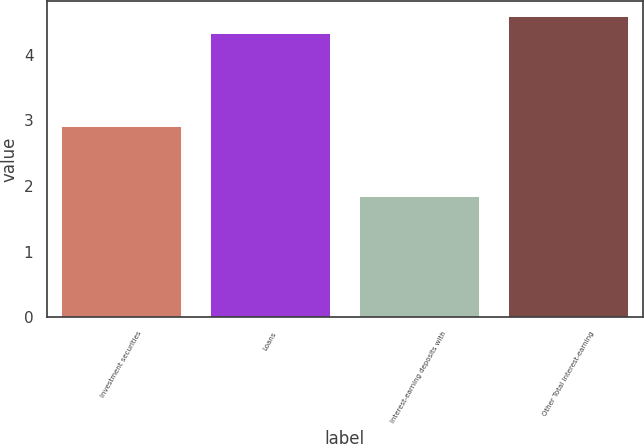Convert chart. <chart><loc_0><loc_0><loc_500><loc_500><bar_chart><fcel>Investment securities<fcel>Loans<fcel>Interest-earning deposits with<fcel>Other Total interest-earning<nl><fcel>2.91<fcel>4.33<fcel>1.84<fcel>4.59<nl></chart> 